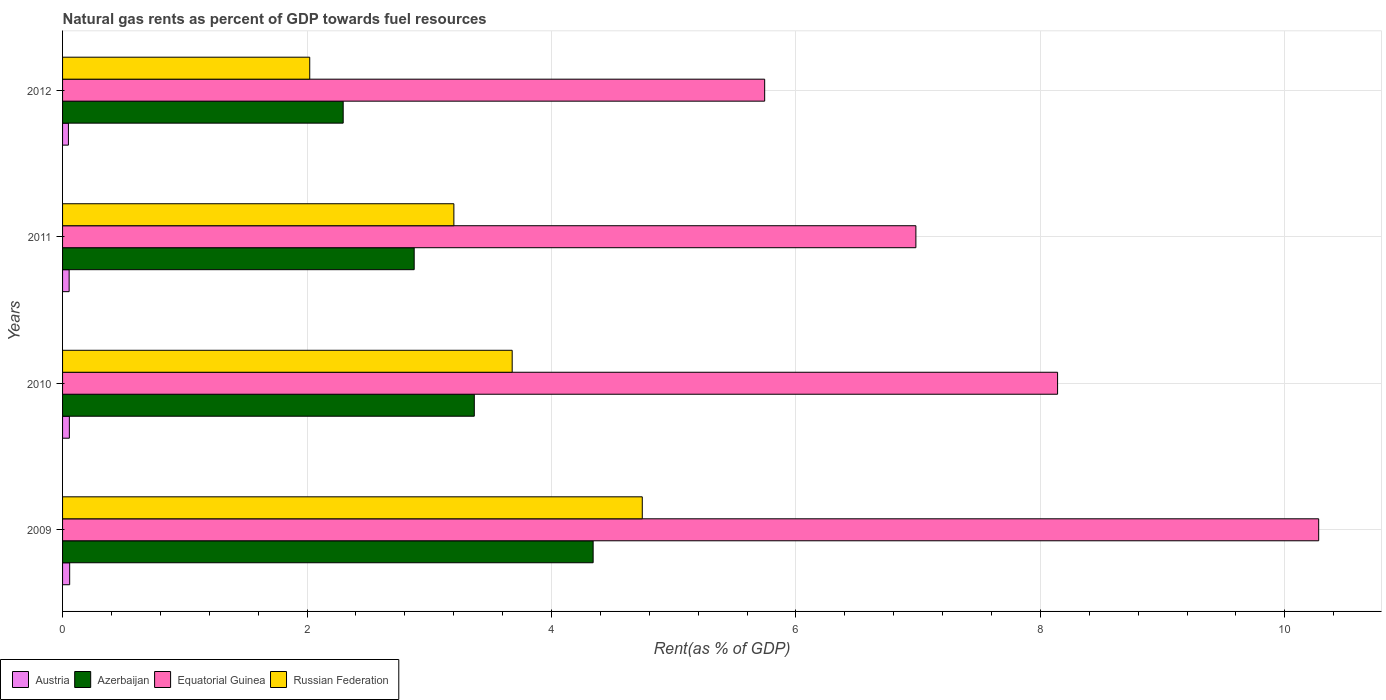Are the number of bars per tick equal to the number of legend labels?
Ensure brevity in your answer.  Yes. How many bars are there on the 1st tick from the top?
Ensure brevity in your answer.  4. How many bars are there on the 2nd tick from the bottom?
Keep it short and to the point. 4. What is the label of the 3rd group of bars from the top?
Offer a very short reply. 2010. What is the matural gas rent in Russian Federation in 2009?
Keep it short and to the point. 4.74. Across all years, what is the maximum matural gas rent in Austria?
Provide a succinct answer. 0.06. Across all years, what is the minimum matural gas rent in Equatorial Guinea?
Make the answer very short. 5.74. In which year was the matural gas rent in Equatorial Guinea minimum?
Your answer should be compact. 2012. What is the total matural gas rent in Equatorial Guinea in the graph?
Your answer should be very brief. 31.14. What is the difference between the matural gas rent in Austria in 2009 and that in 2010?
Your answer should be compact. 0. What is the difference between the matural gas rent in Russian Federation in 2010 and the matural gas rent in Equatorial Guinea in 2009?
Keep it short and to the point. -6.6. What is the average matural gas rent in Russian Federation per year?
Make the answer very short. 3.41. In the year 2009, what is the difference between the matural gas rent in Russian Federation and matural gas rent in Austria?
Offer a terse response. 4.68. What is the ratio of the matural gas rent in Equatorial Guinea in 2011 to that in 2012?
Make the answer very short. 1.22. Is the matural gas rent in Equatorial Guinea in 2010 less than that in 2011?
Make the answer very short. No. Is the difference between the matural gas rent in Russian Federation in 2010 and 2012 greater than the difference between the matural gas rent in Austria in 2010 and 2012?
Make the answer very short. Yes. What is the difference between the highest and the second highest matural gas rent in Russian Federation?
Your answer should be very brief. 1.06. What is the difference between the highest and the lowest matural gas rent in Azerbaijan?
Provide a short and direct response. 2.04. In how many years, is the matural gas rent in Russian Federation greater than the average matural gas rent in Russian Federation taken over all years?
Provide a succinct answer. 2. Is the sum of the matural gas rent in Azerbaijan in 2010 and 2011 greater than the maximum matural gas rent in Equatorial Guinea across all years?
Offer a very short reply. No. What does the 3rd bar from the bottom in 2010 represents?
Ensure brevity in your answer.  Equatorial Guinea. How many bars are there?
Your response must be concise. 16. Are all the bars in the graph horizontal?
Keep it short and to the point. Yes. What is the difference between two consecutive major ticks on the X-axis?
Your response must be concise. 2. Are the values on the major ticks of X-axis written in scientific E-notation?
Offer a terse response. No. Does the graph contain grids?
Your response must be concise. Yes. What is the title of the graph?
Your answer should be very brief. Natural gas rents as percent of GDP towards fuel resources. What is the label or title of the X-axis?
Give a very brief answer. Rent(as % of GDP). What is the label or title of the Y-axis?
Provide a succinct answer. Years. What is the Rent(as % of GDP) of Austria in 2009?
Provide a succinct answer. 0.06. What is the Rent(as % of GDP) of Azerbaijan in 2009?
Provide a succinct answer. 4.34. What is the Rent(as % of GDP) in Equatorial Guinea in 2009?
Provide a succinct answer. 10.28. What is the Rent(as % of GDP) in Russian Federation in 2009?
Provide a succinct answer. 4.74. What is the Rent(as % of GDP) of Austria in 2010?
Offer a terse response. 0.06. What is the Rent(as % of GDP) of Azerbaijan in 2010?
Give a very brief answer. 3.37. What is the Rent(as % of GDP) of Equatorial Guinea in 2010?
Provide a succinct answer. 8.14. What is the Rent(as % of GDP) in Russian Federation in 2010?
Give a very brief answer. 3.68. What is the Rent(as % of GDP) in Austria in 2011?
Keep it short and to the point. 0.05. What is the Rent(as % of GDP) of Azerbaijan in 2011?
Your answer should be very brief. 2.88. What is the Rent(as % of GDP) of Equatorial Guinea in 2011?
Ensure brevity in your answer.  6.98. What is the Rent(as % of GDP) in Russian Federation in 2011?
Keep it short and to the point. 3.2. What is the Rent(as % of GDP) in Austria in 2012?
Your answer should be compact. 0.05. What is the Rent(as % of GDP) of Azerbaijan in 2012?
Provide a short and direct response. 2.3. What is the Rent(as % of GDP) of Equatorial Guinea in 2012?
Provide a short and direct response. 5.74. What is the Rent(as % of GDP) of Russian Federation in 2012?
Give a very brief answer. 2.02. Across all years, what is the maximum Rent(as % of GDP) in Austria?
Your answer should be compact. 0.06. Across all years, what is the maximum Rent(as % of GDP) in Azerbaijan?
Provide a succinct answer. 4.34. Across all years, what is the maximum Rent(as % of GDP) of Equatorial Guinea?
Your answer should be very brief. 10.28. Across all years, what is the maximum Rent(as % of GDP) of Russian Federation?
Your answer should be very brief. 4.74. Across all years, what is the minimum Rent(as % of GDP) of Austria?
Keep it short and to the point. 0.05. Across all years, what is the minimum Rent(as % of GDP) in Azerbaijan?
Offer a very short reply. 2.3. Across all years, what is the minimum Rent(as % of GDP) in Equatorial Guinea?
Provide a short and direct response. 5.74. Across all years, what is the minimum Rent(as % of GDP) in Russian Federation?
Ensure brevity in your answer.  2.02. What is the total Rent(as % of GDP) of Austria in the graph?
Give a very brief answer. 0.22. What is the total Rent(as % of GDP) of Azerbaijan in the graph?
Give a very brief answer. 12.88. What is the total Rent(as % of GDP) in Equatorial Guinea in the graph?
Offer a very short reply. 31.14. What is the total Rent(as % of GDP) of Russian Federation in the graph?
Provide a succinct answer. 13.65. What is the difference between the Rent(as % of GDP) of Austria in 2009 and that in 2010?
Keep it short and to the point. 0. What is the difference between the Rent(as % of GDP) in Azerbaijan in 2009 and that in 2010?
Provide a succinct answer. 0.97. What is the difference between the Rent(as % of GDP) in Equatorial Guinea in 2009 and that in 2010?
Offer a very short reply. 2.14. What is the difference between the Rent(as % of GDP) of Russian Federation in 2009 and that in 2010?
Provide a succinct answer. 1.06. What is the difference between the Rent(as % of GDP) of Austria in 2009 and that in 2011?
Offer a terse response. 0. What is the difference between the Rent(as % of GDP) in Azerbaijan in 2009 and that in 2011?
Provide a short and direct response. 1.46. What is the difference between the Rent(as % of GDP) of Equatorial Guinea in 2009 and that in 2011?
Give a very brief answer. 3.3. What is the difference between the Rent(as % of GDP) in Russian Federation in 2009 and that in 2011?
Keep it short and to the point. 1.54. What is the difference between the Rent(as % of GDP) in Austria in 2009 and that in 2012?
Your answer should be compact. 0.01. What is the difference between the Rent(as % of GDP) of Azerbaijan in 2009 and that in 2012?
Keep it short and to the point. 2.04. What is the difference between the Rent(as % of GDP) of Equatorial Guinea in 2009 and that in 2012?
Your answer should be very brief. 4.53. What is the difference between the Rent(as % of GDP) in Russian Federation in 2009 and that in 2012?
Your answer should be compact. 2.72. What is the difference between the Rent(as % of GDP) of Austria in 2010 and that in 2011?
Provide a short and direct response. 0. What is the difference between the Rent(as % of GDP) in Azerbaijan in 2010 and that in 2011?
Your answer should be compact. 0.49. What is the difference between the Rent(as % of GDP) in Equatorial Guinea in 2010 and that in 2011?
Your response must be concise. 1.16. What is the difference between the Rent(as % of GDP) of Russian Federation in 2010 and that in 2011?
Your response must be concise. 0.48. What is the difference between the Rent(as % of GDP) of Austria in 2010 and that in 2012?
Your answer should be very brief. 0.01. What is the difference between the Rent(as % of GDP) of Azerbaijan in 2010 and that in 2012?
Make the answer very short. 1.07. What is the difference between the Rent(as % of GDP) of Equatorial Guinea in 2010 and that in 2012?
Keep it short and to the point. 2.4. What is the difference between the Rent(as % of GDP) of Russian Federation in 2010 and that in 2012?
Provide a short and direct response. 1.66. What is the difference between the Rent(as % of GDP) in Austria in 2011 and that in 2012?
Your answer should be very brief. 0.01. What is the difference between the Rent(as % of GDP) of Azerbaijan in 2011 and that in 2012?
Offer a very short reply. 0.58. What is the difference between the Rent(as % of GDP) of Equatorial Guinea in 2011 and that in 2012?
Provide a succinct answer. 1.24. What is the difference between the Rent(as % of GDP) in Russian Federation in 2011 and that in 2012?
Your response must be concise. 1.18. What is the difference between the Rent(as % of GDP) in Austria in 2009 and the Rent(as % of GDP) in Azerbaijan in 2010?
Ensure brevity in your answer.  -3.31. What is the difference between the Rent(as % of GDP) of Austria in 2009 and the Rent(as % of GDP) of Equatorial Guinea in 2010?
Provide a succinct answer. -8.08. What is the difference between the Rent(as % of GDP) of Austria in 2009 and the Rent(as % of GDP) of Russian Federation in 2010?
Give a very brief answer. -3.62. What is the difference between the Rent(as % of GDP) of Azerbaijan in 2009 and the Rent(as % of GDP) of Equatorial Guinea in 2010?
Make the answer very short. -3.8. What is the difference between the Rent(as % of GDP) in Azerbaijan in 2009 and the Rent(as % of GDP) in Russian Federation in 2010?
Your response must be concise. 0.66. What is the difference between the Rent(as % of GDP) of Equatorial Guinea in 2009 and the Rent(as % of GDP) of Russian Federation in 2010?
Your answer should be very brief. 6.6. What is the difference between the Rent(as % of GDP) in Austria in 2009 and the Rent(as % of GDP) in Azerbaijan in 2011?
Give a very brief answer. -2.82. What is the difference between the Rent(as % of GDP) of Austria in 2009 and the Rent(as % of GDP) of Equatorial Guinea in 2011?
Provide a succinct answer. -6.92. What is the difference between the Rent(as % of GDP) in Austria in 2009 and the Rent(as % of GDP) in Russian Federation in 2011?
Your answer should be very brief. -3.14. What is the difference between the Rent(as % of GDP) in Azerbaijan in 2009 and the Rent(as % of GDP) in Equatorial Guinea in 2011?
Offer a very short reply. -2.64. What is the difference between the Rent(as % of GDP) in Azerbaijan in 2009 and the Rent(as % of GDP) in Russian Federation in 2011?
Your answer should be compact. 1.14. What is the difference between the Rent(as % of GDP) of Equatorial Guinea in 2009 and the Rent(as % of GDP) of Russian Federation in 2011?
Your answer should be very brief. 7.08. What is the difference between the Rent(as % of GDP) of Austria in 2009 and the Rent(as % of GDP) of Azerbaijan in 2012?
Ensure brevity in your answer.  -2.24. What is the difference between the Rent(as % of GDP) of Austria in 2009 and the Rent(as % of GDP) of Equatorial Guinea in 2012?
Make the answer very short. -5.69. What is the difference between the Rent(as % of GDP) in Austria in 2009 and the Rent(as % of GDP) in Russian Federation in 2012?
Your answer should be compact. -1.96. What is the difference between the Rent(as % of GDP) of Azerbaijan in 2009 and the Rent(as % of GDP) of Equatorial Guinea in 2012?
Provide a succinct answer. -1.4. What is the difference between the Rent(as % of GDP) of Azerbaijan in 2009 and the Rent(as % of GDP) of Russian Federation in 2012?
Your answer should be compact. 2.32. What is the difference between the Rent(as % of GDP) in Equatorial Guinea in 2009 and the Rent(as % of GDP) in Russian Federation in 2012?
Ensure brevity in your answer.  8.25. What is the difference between the Rent(as % of GDP) of Austria in 2010 and the Rent(as % of GDP) of Azerbaijan in 2011?
Provide a succinct answer. -2.82. What is the difference between the Rent(as % of GDP) in Austria in 2010 and the Rent(as % of GDP) in Equatorial Guinea in 2011?
Make the answer very short. -6.93. What is the difference between the Rent(as % of GDP) in Austria in 2010 and the Rent(as % of GDP) in Russian Federation in 2011?
Your response must be concise. -3.15. What is the difference between the Rent(as % of GDP) of Azerbaijan in 2010 and the Rent(as % of GDP) of Equatorial Guinea in 2011?
Offer a very short reply. -3.61. What is the difference between the Rent(as % of GDP) of Azerbaijan in 2010 and the Rent(as % of GDP) of Russian Federation in 2011?
Your answer should be compact. 0.17. What is the difference between the Rent(as % of GDP) of Equatorial Guinea in 2010 and the Rent(as % of GDP) of Russian Federation in 2011?
Your response must be concise. 4.94. What is the difference between the Rent(as % of GDP) of Austria in 2010 and the Rent(as % of GDP) of Azerbaijan in 2012?
Keep it short and to the point. -2.24. What is the difference between the Rent(as % of GDP) in Austria in 2010 and the Rent(as % of GDP) in Equatorial Guinea in 2012?
Provide a short and direct response. -5.69. What is the difference between the Rent(as % of GDP) of Austria in 2010 and the Rent(as % of GDP) of Russian Federation in 2012?
Give a very brief answer. -1.97. What is the difference between the Rent(as % of GDP) of Azerbaijan in 2010 and the Rent(as % of GDP) of Equatorial Guinea in 2012?
Offer a terse response. -2.38. What is the difference between the Rent(as % of GDP) of Azerbaijan in 2010 and the Rent(as % of GDP) of Russian Federation in 2012?
Offer a very short reply. 1.35. What is the difference between the Rent(as % of GDP) of Equatorial Guinea in 2010 and the Rent(as % of GDP) of Russian Federation in 2012?
Your answer should be very brief. 6.12. What is the difference between the Rent(as % of GDP) in Austria in 2011 and the Rent(as % of GDP) in Azerbaijan in 2012?
Your answer should be very brief. -2.24. What is the difference between the Rent(as % of GDP) of Austria in 2011 and the Rent(as % of GDP) of Equatorial Guinea in 2012?
Keep it short and to the point. -5.69. What is the difference between the Rent(as % of GDP) of Austria in 2011 and the Rent(as % of GDP) of Russian Federation in 2012?
Ensure brevity in your answer.  -1.97. What is the difference between the Rent(as % of GDP) in Azerbaijan in 2011 and the Rent(as % of GDP) in Equatorial Guinea in 2012?
Make the answer very short. -2.87. What is the difference between the Rent(as % of GDP) in Azerbaijan in 2011 and the Rent(as % of GDP) in Russian Federation in 2012?
Keep it short and to the point. 0.85. What is the difference between the Rent(as % of GDP) in Equatorial Guinea in 2011 and the Rent(as % of GDP) in Russian Federation in 2012?
Ensure brevity in your answer.  4.96. What is the average Rent(as % of GDP) of Austria per year?
Offer a terse response. 0.05. What is the average Rent(as % of GDP) in Azerbaijan per year?
Offer a very short reply. 3.22. What is the average Rent(as % of GDP) of Equatorial Guinea per year?
Provide a succinct answer. 7.79. What is the average Rent(as % of GDP) in Russian Federation per year?
Your answer should be compact. 3.41. In the year 2009, what is the difference between the Rent(as % of GDP) in Austria and Rent(as % of GDP) in Azerbaijan?
Provide a succinct answer. -4.28. In the year 2009, what is the difference between the Rent(as % of GDP) in Austria and Rent(as % of GDP) in Equatorial Guinea?
Ensure brevity in your answer.  -10.22. In the year 2009, what is the difference between the Rent(as % of GDP) of Austria and Rent(as % of GDP) of Russian Federation?
Offer a very short reply. -4.68. In the year 2009, what is the difference between the Rent(as % of GDP) in Azerbaijan and Rent(as % of GDP) in Equatorial Guinea?
Offer a very short reply. -5.94. In the year 2009, what is the difference between the Rent(as % of GDP) of Azerbaijan and Rent(as % of GDP) of Russian Federation?
Your response must be concise. -0.4. In the year 2009, what is the difference between the Rent(as % of GDP) in Equatorial Guinea and Rent(as % of GDP) in Russian Federation?
Provide a short and direct response. 5.53. In the year 2010, what is the difference between the Rent(as % of GDP) of Austria and Rent(as % of GDP) of Azerbaijan?
Offer a very short reply. -3.31. In the year 2010, what is the difference between the Rent(as % of GDP) in Austria and Rent(as % of GDP) in Equatorial Guinea?
Offer a very short reply. -8.09. In the year 2010, what is the difference between the Rent(as % of GDP) of Austria and Rent(as % of GDP) of Russian Federation?
Offer a terse response. -3.62. In the year 2010, what is the difference between the Rent(as % of GDP) in Azerbaijan and Rent(as % of GDP) in Equatorial Guinea?
Offer a terse response. -4.77. In the year 2010, what is the difference between the Rent(as % of GDP) of Azerbaijan and Rent(as % of GDP) of Russian Federation?
Your answer should be very brief. -0.31. In the year 2010, what is the difference between the Rent(as % of GDP) of Equatorial Guinea and Rent(as % of GDP) of Russian Federation?
Make the answer very short. 4.46. In the year 2011, what is the difference between the Rent(as % of GDP) of Austria and Rent(as % of GDP) of Azerbaijan?
Provide a short and direct response. -2.82. In the year 2011, what is the difference between the Rent(as % of GDP) of Austria and Rent(as % of GDP) of Equatorial Guinea?
Your answer should be compact. -6.93. In the year 2011, what is the difference between the Rent(as % of GDP) of Austria and Rent(as % of GDP) of Russian Federation?
Your answer should be very brief. -3.15. In the year 2011, what is the difference between the Rent(as % of GDP) in Azerbaijan and Rent(as % of GDP) in Equatorial Guinea?
Offer a very short reply. -4.1. In the year 2011, what is the difference between the Rent(as % of GDP) of Azerbaijan and Rent(as % of GDP) of Russian Federation?
Provide a short and direct response. -0.32. In the year 2011, what is the difference between the Rent(as % of GDP) in Equatorial Guinea and Rent(as % of GDP) in Russian Federation?
Make the answer very short. 3.78. In the year 2012, what is the difference between the Rent(as % of GDP) of Austria and Rent(as % of GDP) of Azerbaijan?
Provide a short and direct response. -2.25. In the year 2012, what is the difference between the Rent(as % of GDP) in Austria and Rent(as % of GDP) in Equatorial Guinea?
Offer a very short reply. -5.7. In the year 2012, what is the difference between the Rent(as % of GDP) in Austria and Rent(as % of GDP) in Russian Federation?
Ensure brevity in your answer.  -1.97. In the year 2012, what is the difference between the Rent(as % of GDP) of Azerbaijan and Rent(as % of GDP) of Equatorial Guinea?
Make the answer very short. -3.45. In the year 2012, what is the difference between the Rent(as % of GDP) in Azerbaijan and Rent(as % of GDP) in Russian Federation?
Ensure brevity in your answer.  0.27. In the year 2012, what is the difference between the Rent(as % of GDP) of Equatorial Guinea and Rent(as % of GDP) of Russian Federation?
Provide a short and direct response. 3.72. What is the ratio of the Rent(as % of GDP) of Austria in 2009 to that in 2010?
Give a very brief answer. 1.04. What is the ratio of the Rent(as % of GDP) in Azerbaijan in 2009 to that in 2010?
Keep it short and to the point. 1.29. What is the ratio of the Rent(as % of GDP) in Equatorial Guinea in 2009 to that in 2010?
Offer a terse response. 1.26. What is the ratio of the Rent(as % of GDP) of Russian Federation in 2009 to that in 2010?
Give a very brief answer. 1.29. What is the ratio of the Rent(as % of GDP) in Austria in 2009 to that in 2011?
Give a very brief answer. 1.08. What is the ratio of the Rent(as % of GDP) in Azerbaijan in 2009 to that in 2011?
Offer a terse response. 1.51. What is the ratio of the Rent(as % of GDP) of Equatorial Guinea in 2009 to that in 2011?
Offer a very short reply. 1.47. What is the ratio of the Rent(as % of GDP) in Russian Federation in 2009 to that in 2011?
Offer a terse response. 1.48. What is the ratio of the Rent(as % of GDP) of Austria in 2009 to that in 2012?
Ensure brevity in your answer.  1.21. What is the ratio of the Rent(as % of GDP) of Azerbaijan in 2009 to that in 2012?
Ensure brevity in your answer.  1.89. What is the ratio of the Rent(as % of GDP) of Equatorial Guinea in 2009 to that in 2012?
Your answer should be compact. 1.79. What is the ratio of the Rent(as % of GDP) in Russian Federation in 2009 to that in 2012?
Offer a very short reply. 2.35. What is the ratio of the Rent(as % of GDP) in Austria in 2010 to that in 2011?
Make the answer very short. 1.03. What is the ratio of the Rent(as % of GDP) of Azerbaijan in 2010 to that in 2011?
Keep it short and to the point. 1.17. What is the ratio of the Rent(as % of GDP) in Equatorial Guinea in 2010 to that in 2011?
Your answer should be compact. 1.17. What is the ratio of the Rent(as % of GDP) in Russian Federation in 2010 to that in 2011?
Make the answer very short. 1.15. What is the ratio of the Rent(as % of GDP) in Austria in 2010 to that in 2012?
Provide a short and direct response. 1.16. What is the ratio of the Rent(as % of GDP) in Azerbaijan in 2010 to that in 2012?
Give a very brief answer. 1.47. What is the ratio of the Rent(as % of GDP) of Equatorial Guinea in 2010 to that in 2012?
Give a very brief answer. 1.42. What is the ratio of the Rent(as % of GDP) in Russian Federation in 2010 to that in 2012?
Your answer should be compact. 1.82. What is the ratio of the Rent(as % of GDP) of Austria in 2011 to that in 2012?
Provide a short and direct response. 1.12. What is the ratio of the Rent(as % of GDP) of Azerbaijan in 2011 to that in 2012?
Make the answer very short. 1.25. What is the ratio of the Rent(as % of GDP) in Equatorial Guinea in 2011 to that in 2012?
Make the answer very short. 1.22. What is the ratio of the Rent(as % of GDP) of Russian Federation in 2011 to that in 2012?
Your answer should be compact. 1.58. What is the difference between the highest and the second highest Rent(as % of GDP) in Austria?
Offer a very short reply. 0. What is the difference between the highest and the second highest Rent(as % of GDP) in Azerbaijan?
Offer a very short reply. 0.97. What is the difference between the highest and the second highest Rent(as % of GDP) of Equatorial Guinea?
Give a very brief answer. 2.14. What is the difference between the highest and the second highest Rent(as % of GDP) in Russian Federation?
Your answer should be compact. 1.06. What is the difference between the highest and the lowest Rent(as % of GDP) of Austria?
Ensure brevity in your answer.  0.01. What is the difference between the highest and the lowest Rent(as % of GDP) in Azerbaijan?
Ensure brevity in your answer.  2.04. What is the difference between the highest and the lowest Rent(as % of GDP) in Equatorial Guinea?
Your answer should be compact. 4.53. What is the difference between the highest and the lowest Rent(as % of GDP) in Russian Federation?
Ensure brevity in your answer.  2.72. 